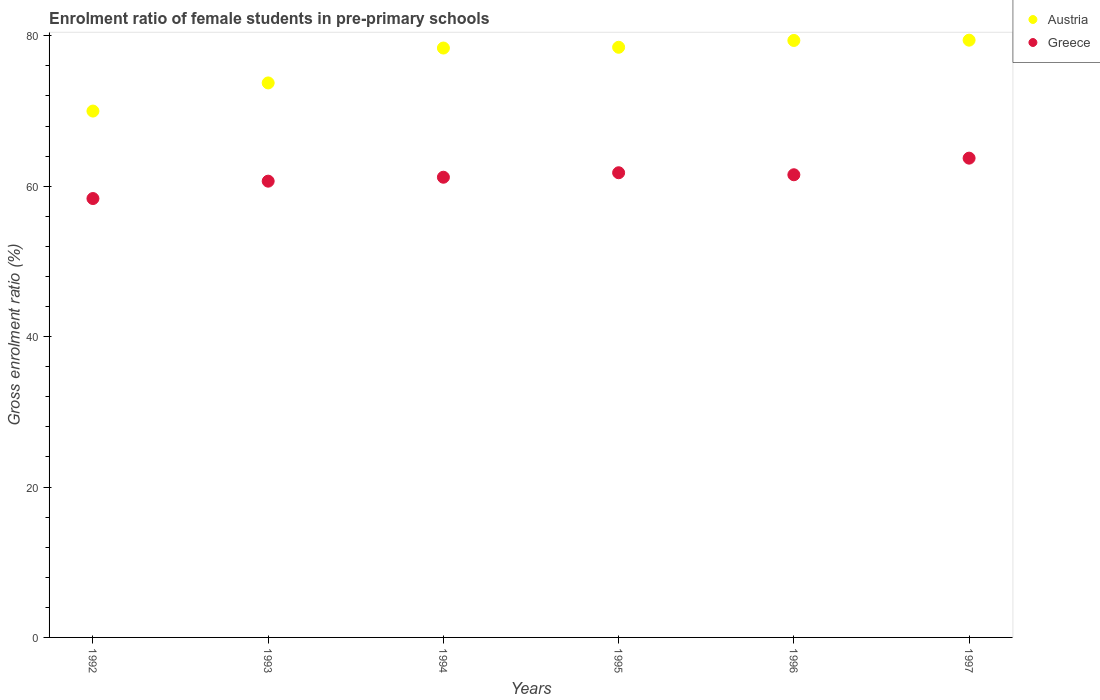How many different coloured dotlines are there?
Your answer should be very brief. 2. What is the enrolment ratio of female students in pre-primary schools in Austria in 1993?
Keep it short and to the point. 73.73. Across all years, what is the maximum enrolment ratio of female students in pre-primary schools in Austria?
Offer a terse response. 79.42. Across all years, what is the minimum enrolment ratio of female students in pre-primary schools in Austria?
Keep it short and to the point. 69.99. In which year was the enrolment ratio of female students in pre-primary schools in Greece minimum?
Your response must be concise. 1992. What is the total enrolment ratio of female students in pre-primary schools in Greece in the graph?
Provide a succinct answer. 367.27. What is the difference between the enrolment ratio of female students in pre-primary schools in Austria in 1993 and that in 1995?
Offer a very short reply. -4.74. What is the difference between the enrolment ratio of female students in pre-primary schools in Greece in 1995 and the enrolment ratio of female students in pre-primary schools in Austria in 1996?
Offer a very short reply. -17.59. What is the average enrolment ratio of female students in pre-primary schools in Austria per year?
Your response must be concise. 76.56. In the year 1993, what is the difference between the enrolment ratio of female students in pre-primary schools in Greece and enrolment ratio of female students in pre-primary schools in Austria?
Make the answer very short. -13.06. What is the ratio of the enrolment ratio of female students in pre-primary schools in Austria in 1994 to that in 1997?
Offer a very short reply. 0.99. What is the difference between the highest and the second highest enrolment ratio of female students in pre-primary schools in Greece?
Ensure brevity in your answer.  1.94. What is the difference between the highest and the lowest enrolment ratio of female students in pre-primary schools in Austria?
Give a very brief answer. 9.43. Is the sum of the enrolment ratio of female students in pre-primary schools in Greece in 1992 and 1997 greater than the maximum enrolment ratio of female students in pre-primary schools in Austria across all years?
Offer a terse response. Yes. How many dotlines are there?
Your answer should be compact. 2. Does the graph contain grids?
Offer a terse response. No. Where does the legend appear in the graph?
Give a very brief answer. Top right. How many legend labels are there?
Your answer should be compact. 2. What is the title of the graph?
Provide a succinct answer. Enrolment ratio of female students in pre-primary schools. What is the label or title of the X-axis?
Offer a very short reply. Years. What is the label or title of the Y-axis?
Offer a very short reply. Gross enrolment ratio (%). What is the Gross enrolment ratio (%) of Austria in 1992?
Offer a terse response. 69.99. What is the Gross enrolment ratio (%) in Greece in 1992?
Keep it short and to the point. 58.36. What is the Gross enrolment ratio (%) in Austria in 1993?
Offer a very short reply. 73.73. What is the Gross enrolment ratio (%) of Greece in 1993?
Keep it short and to the point. 60.67. What is the Gross enrolment ratio (%) of Austria in 1994?
Make the answer very short. 78.37. What is the Gross enrolment ratio (%) of Greece in 1994?
Keep it short and to the point. 61.19. What is the Gross enrolment ratio (%) in Austria in 1995?
Make the answer very short. 78.48. What is the Gross enrolment ratio (%) in Greece in 1995?
Keep it short and to the point. 61.79. What is the Gross enrolment ratio (%) of Austria in 1996?
Provide a succinct answer. 79.38. What is the Gross enrolment ratio (%) of Greece in 1996?
Provide a short and direct response. 61.52. What is the Gross enrolment ratio (%) in Austria in 1997?
Your response must be concise. 79.42. What is the Gross enrolment ratio (%) in Greece in 1997?
Offer a very short reply. 63.73. Across all years, what is the maximum Gross enrolment ratio (%) in Austria?
Your response must be concise. 79.42. Across all years, what is the maximum Gross enrolment ratio (%) of Greece?
Your answer should be very brief. 63.73. Across all years, what is the minimum Gross enrolment ratio (%) of Austria?
Your response must be concise. 69.99. Across all years, what is the minimum Gross enrolment ratio (%) of Greece?
Offer a terse response. 58.36. What is the total Gross enrolment ratio (%) of Austria in the graph?
Ensure brevity in your answer.  459.37. What is the total Gross enrolment ratio (%) in Greece in the graph?
Make the answer very short. 367.27. What is the difference between the Gross enrolment ratio (%) of Austria in 1992 and that in 1993?
Provide a short and direct response. -3.74. What is the difference between the Gross enrolment ratio (%) of Greece in 1992 and that in 1993?
Offer a very short reply. -2.31. What is the difference between the Gross enrolment ratio (%) in Austria in 1992 and that in 1994?
Make the answer very short. -8.38. What is the difference between the Gross enrolment ratio (%) in Greece in 1992 and that in 1994?
Make the answer very short. -2.83. What is the difference between the Gross enrolment ratio (%) in Austria in 1992 and that in 1995?
Your answer should be very brief. -8.48. What is the difference between the Gross enrolment ratio (%) in Greece in 1992 and that in 1995?
Offer a very short reply. -3.43. What is the difference between the Gross enrolment ratio (%) of Austria in 1992 and that in 1996?
Provide a succinct answer. -9.39. What is the difference between the Gross enrolment ratio (%) in Greece in 1992 and that in 1996?
Your answer should be compact. -3.16. What is the difference between the Gross enrolment ratio (%) of Austria in 1992 and that in 1997?
Provide a succinct answer. -9.43. What is the difference between the Gross enrolment ratio (%) in Greece in 1992 and that in 1997?
Keep it short and to the point. -5.37. What is the difference between the Gross enrolment ratio (%) in Austria in 1993 and that in 1994?
Offer a very short reply. -4.64. What is the difference between the Gross enrolment ratio (%) of Greece in 1993 and that in 1994?
Offer a very short reply. -0.52. What is the difference between the Gross enrolment ratio (%) of Austria in 1993 and that in 1995?
Your answer should be very brief. -4.74. What is the difference between the Gross enrolment ratio (%) in Greece in 1993 and that in 1995?
Ensure brevity in your answer.  -1.12. What is the difference between the Gross enrolment ratio (%) in Austria in 1993 and that in 1996?
Keep it short and to the point. -5.65. What is the difference between the Gross enrolment ratio (%) in Greece in 1993 and that in 1996?
Provide a short and direct response. -0.85. What is the difference between the Gross enrolment ratio (%) in Austria in 1993 and that in 1997?
Offer a very short reply. -5.69. What is the difference between the Gross enrolment ratio (%) of Greece in 1993 and that in 1997?
Make the answer very short. -3.06. What is the difference between the Gross enrolment ratio (%) of Austria in 1994 and that in 1995?
Offer a very short reply. -0.1. What is the difference between the Gross enrolment ratio (%) of Greece in 1994 and that in 1995?
Your response must be concise. -0.6. What is the difference between the Gross enrolment ratio (%) of Austria in 1994 and that in 1996?
Your response must be concise. -1.01. What is the difference between the Gross enrolment ratio (%) in Greece in 1994 and that in 1996?
Ensure brevity in your answer.  -0.33. What is the difference between the Gross enrolment ratio (%) of Austria in 1994 and that in 1997?
Provide a short and direct response. -1.05. What is the difference between the Gross enrolment ratio (%) of Greece in 1994 and that in 1997?
Provide a short and direct response. -2.54. What is the difference between the Gross enrolment ratio (%) in Austria in 1995 and that in 1996?
Provide a short and direct response. -0.91. What is the difference between the Gross enrolment ratio (%) of Greece in 1995 and that in 1996?
Ensure brevity in your answer.  0.27. What is the difference between the Gross enrolment ratio (%) of Austria in 1995 and that in 1997?
Your answer should be compact. -0.94. What is the difference between the Gross enrolment ratio (%) of Greece in 1995 and that in 1997?
Provide a succinct answer. -1.94. What is the difference between the Gross enrolment ratio (%) in Austria in 1996 and that in 1997?
Your response must be concise. -0.04. What is the difference between the Gross enrolment ratio (%) of Greece in 1996 and that in 1997?
Provide a succinct answer. -2.21. What is the difference between the Gross enrolment ratio (%) of Austria in 1992 and the Gross enrolment ratio (%) of Greece in 1993?
Give a very brief answer. 9.32. What is the difference between the Gross enrolment ratio (%) of Austria in 1992 and the Gross enrolment ratio (%) of Greece in 1994?
Keep it short and to the point. 8.8. What is the difference between the Gross enrolment ratio (%) of Austria in 1992 and the Gross enrolment ratio (%) of Greece in 1995?
Ensure brevity in your answer.  8.2. What is the difference between the Gross enrolment ratio (%) of Austria in 1992 and the Gross enrolment ratio (%) of Greece in 1996?
Offer a very short reply. 8.47. What is the difference between the Gross enrolment ratio (%) of Austria in 1992 and the Gross enrolment ratio (%) of Greece in 1997?
Give a very brief answer. 6.26. What is the difference between the Gross enrolment ratio (%) of Austria in 1993 and the Gross enrolment ratio (%) of Greece in 1994?
Offer a terse response. 12.54. What is the difference between the Gross enrolment ratio (%) in Austria in 1993 and the Gross enrolment ratio (%) in Greece in 1995?
Offer a very short reply. 11.94. What is the difference between the Gross enrolment ratio (%) in Austria in 1993 and the Gross enrolment ratio (%) in Greece in 1996?
Ensure brevity in your answer.  12.21. What is the difference between the Gross enrolment ratio (%) of Austria in 1993 and the Gross enrolment ratio (%) of Greece in 1997?
Your answer should be compact. 10. What is the difference between the Gross enrolment ratio (%) of Austria in 1994 and the Gross enrolment ratio (%) of Greece in 1995?
Keep it short and to the point. 16.58. What is the difference between the Gross enrolment ratio (%) in Austria in 1994 and the Gross enrolment ratio (%) in Greece in 1996?
Keep it short and to the point. 16.85. What is the difference between the Gross enrolment ratio (%) of Austria in 1994 and the Gross enrolment ratio (%) of Greece in 1997?
Your response must be concise. 14.64. What is the difference between the Gross enrolment ratio (%) of Austria in 1995 and the Gross enrolment ratio (%) of Greece in 1996?
Give a very brief answer. 16.95. What is the difference between the Gross enrolment ratio (%) in Austria in 1995 and the Gross enrolment ratio (%) in Greece in 1997?
Give a very brief answer. 14.74. What is the difference between the Gross enrolment ratio (%) in Austria in 1996 and the Gross enrolment ratio (%) in Greece in 1997?
Offer a very short reply. 15.65. What is the average Gross enrolment ratio (%) of Austria per year?
Provide a succinct answer. 76.56. What is the average Gross enrolment ratio (%) of Greece per year?
Keep it short and to the point. 61.21. In the year 1992, what is the difference between the Gross enrolment ratio (%) in Austria and Gross enrolment ratio (%) in Greece?
Keep it short and to the point. 11.63. In the year 1993, what is the difference between the Gross enrolment ratio (%) in Austria and Gross enrolment ratio (%) in Greece?
Your answer should be very brief. 13.06. In the year 1994, what is the difference between the Gross enrolment ratio (%) in Austria and Gross enrolment ratio (%) in Greece?
Your answer should be very brief. 17.18. In the year 1995, what is the difference between the Gross enrolment ratio (%) of Austria and Gross enrolment ratio (%) of Greece?
Provide a succinct answer. 16.69. In the year 1996, what is the difference between the Gross enrolment ratio (%) of Austria and Gross enrolment ratio (%) of Greece?
Give a very brief answer. 17.86. In the year 1997, what is the difference between the Gross enrolment ratio (%) in Austria and Gross enrolment ratio (%) in Greece?
Your answer should be compact. 15.69. What is the ratio of the Gross enrolment ratio (%) of Austria in 1992 to that in 1993?
Provide a short and direct response. 0.95. What is the ratio of the Gross enrolment ratio (%) in Greece in 1992 to that in 1993?
Ensure brevity in your answer.  0.96. What is the ratio of the Gross enrolment ratio (%) in Austria in 1992 to that in 1994?
Your answer should be very brief. 0.89. What is the ratio of the Gross enrolment ratio (%) in Greece in 1992 to that in 1994?
Your answer should be very brief. 0.95. What is the ratio of the Gross enrolment ratio (%) in Austria in 1992 to that in 1995?
Your answer should be very brief. 0.89. What is the ratio of the Gross enrolment ratio (%) in Greece in 1992 to that in 1995?
Your answer should be very brief. 0.94. What is the ratio of the Gross enrolment ratio (%) of Austria in 1992 to that in 1996?
Your response must be concise. 0.88. What is the ratio of the Gross enrolment ratio (%) of Greece in 1992 to that in 1996?
Provide a succinct answer. 0.95. What is the ratio of the Gross enrolment ratio (%) in Austria in 1992 to that in 1997?
Your answer should be compact. 0.88. What is the ratio of the Gross enrolment ratio (%) of Greece in 1992 to that in 1997?
Your answer should be compact. 0.92. What is the ratio of the Gross enrolment ratio (%) of Austria in 1993 to that in 1994?
Provide a succinct answer. 0.94. What is the ratio of the Gross enrolment ratio (%) in Greece in 1993 to that in 1994?
Make the answer very short. 0.99. What is the ratio of the Gross enrolment ratio (%) in Austria in 1993 to that in 1995?
Your response must be concise. 0.94. What is the ratio of the Gross enrolment ratio (%) of Greece in 1993 to that in 1995?
Ensure brevity in your answer.  0.98. What is the ratio of the Gross enrolment ratio (%) of Austria in 1993 to that in 1996?
Keep it short and to the point. 0.93. What is the ratio of the Gross enrolment ratio (%) in Greece in 1993 to that in 1996?
Ensure brevity in your answer.  0.99. What is the ratio of the Gross enrolment ratio (%) in Austria in 1993 to that in 1997?
Give a very brief answer. 0.93. What is the ratio of the Gross enrolment ratio (%) of Greece in 1993 to that in 1997?
Offer a very short reply. 0.95. What is the ratio of the Gross enrolment ratio (%) in Austria in 1994 to that in 1995?
Your answer should be very brief. 1. What is the ratio of the Gross enrolment ratio (%) in Austria in 1994 to that in 1996?
Keep it short and to the point. 0.99. What is the ratio of the Gross enrolment ratio (%) in Austria in 1994 to that in 1997?
Provide a short and direct response. 0.99. What is the ratio of the Gross enrolment ratio (%) of Greece in 1994 to that in 1997?
Ensure brevity in your answer.  0.96. What is the ratio of the Gross enrolment ratio (%) in Austria in 1995 to that in 1996?
Provide a succinct answer. 0.99. What is the ratio of the Gross enrolment ratio (%) in Greece in 1995 to that in 1997?
Provide a succinct answer. 0.97. What is the ratio of the Gross enrolment ratio (%) of Austria in 1996 to that in 1997?
Ensure brevity in your answer.  1. What is the ratio of the Gross enrolment ratio (%) of Greece in 1996 to that in 1997?
Provide a succinct answer. 0.97. What is the difference between the highest and the second highest Gross enrolment ratio (%) in Austria?
Give a very brief answer. 0.04. What is the difference between the highest and the second highest Gross enrolment ratio (%) in Greece?
Your answer should be very brief. 1.94. What is the difference between the highest and the lowest Gross enrolment ratio (%) in Austria?
Provide a succinct answer. 9.43. What is the difference between the highest and the lowest Gross enrolment ratio (%) in Greece?
Offer a very short reply. 5.37. 